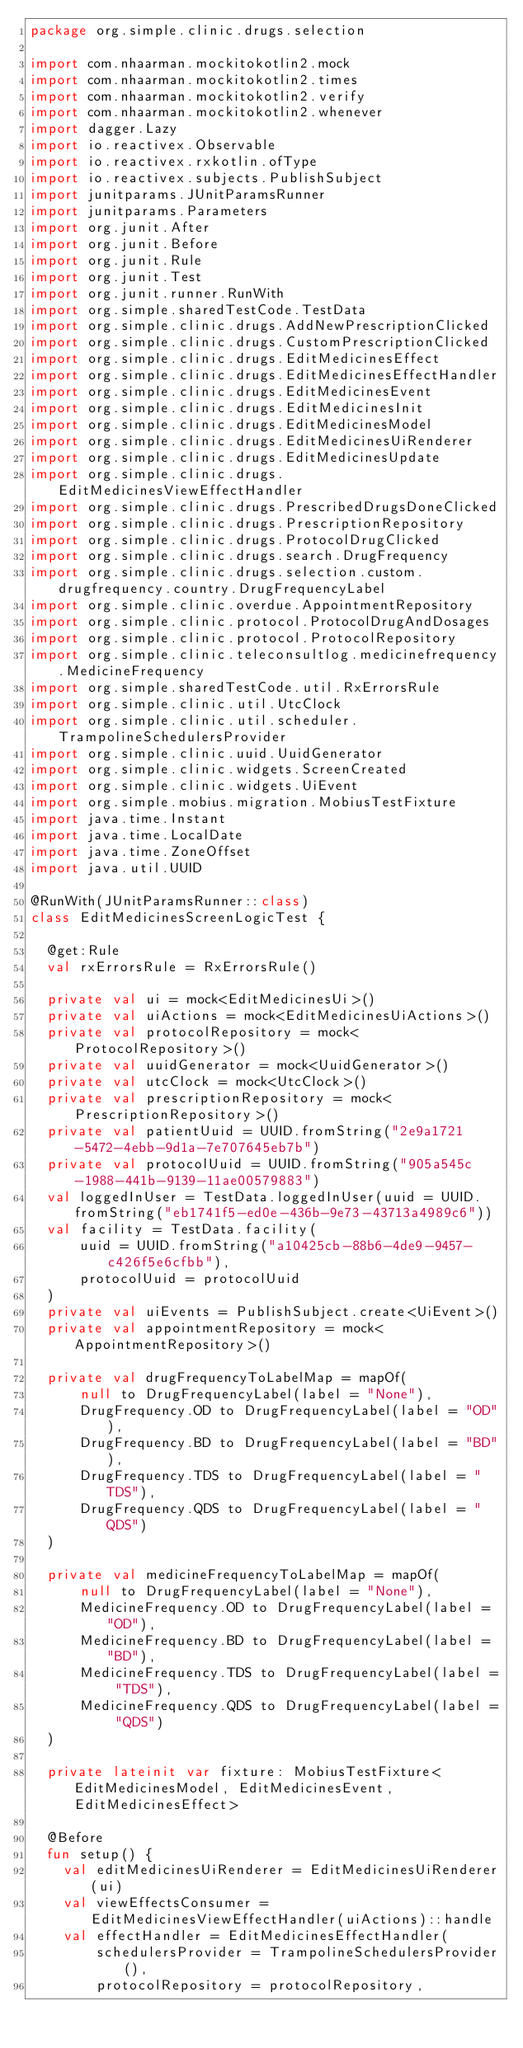Convert code to text. <code><loc_0><loc_0><loc_500><loc_500><_Kotlin_>package org.simple.clinic.drugs.selection

import com.nhaarman.mockitokotlin2.mock
import com.nhaarman.mockitokotlin2.times
import com.nhaarman.mockitokotlin2.verify
import com.nhaarman.mockitokotlin2.whenever
import dagger.Lazy
import io.reactivex.Observable
import io.reactivex.rxkotlin.ofType
import io.reactivex.subjects.PublishSubject
import junitparams.JUnitParamsRunner
import junitparams.Parameters
import org.junit.After
import org.junit.Before
import org.junit.Rule
import org.junit.Test
import org.junit.runner.RunWith
import org.simple.sharedTestCode.TestData
import org.simple.clinic.drugs.AddNewPrescriptionClicked
import org.simple.clinic.drugs.CustomPrescriptionClicked
import org.simple.clinic.drugs.EditMedicinesEffect
import org.simple.clinic.drugs.EditMedicinesEffectHandler
import org.simple.clinic.drugs.EditMedicinesEvent
import org.simple.clinic.drugs.EditMedicinesInit
import org.simple.clinic.drugs.EditMedicinesModel
import org.simple.clinic.drugs.EditMedicinesUiRenderer
import org.simple.clinic.drugs.EditMedicinesUpdate
import org.simple.clinic.drugs.EditMedicinesViewEffectHandler
import org.simple.clinic.drugs.PrescribedDrugsDoneClicked
import org.simple.clinic.drugs.PrescriptionRepository
import org.simple.clinic.drugs.ProtocolDrugClicked
import org.simple.clinic.drugs.search.DrugFrequency
import org.simple.clinic.drugs.selection.custom.drugfrequency.country.DrugFrequencyLabel
import org.simple.clinic.overdue.AppointmentRepository
import org.simple.clinic.protocol.ProtocolDrugAndDosages
import org.simple.clinic.protocol.ProtocolRepository
import org.simple.clinic.teleconsultlog.medicinefrequency.MedicineFrequency
import org.simple.sharedTestCode.util.RxErrorsRule
import org.simple.clinic.util.UtcClock
import org.simple.clinic.util.scheduler.TrampolineSchedulersProvider
import org.simple.clinic.uuid.UuidGenerator
import org.simple.clinic.widgets.ScreenCreated
import org.simple.clinic.widgets.UiEvent
import org.simple.mobius.migration.MobiusTestFixture
import java.time.Instant
import java.time.LocalDate
import java.time.ZoneOffset
import java.util.UUID

@RunWith(JUnitParamsRunner::class)
class EditMedicinesScreenLogicTest {

  @get:Rule
  val rxErrorsRule = RxErrorsRule()

  private val ui = mock<EditMedicinesUi>()
  private val uiActions = mock<EditMedicinesUiActions>()
  private val protocolRepository = mock<ProtocolRepository>()
  private val uuidGenerator = mock<UuidGenerator>()
  private val utcClock = mock<UtcClock>()
  private val prescriptionRepository = mock<PrescriptionRepository>()
  private val patientUuid = UUID.fromString("2e9a1721-5472-4ebb-9d1a-7e707645eb7b")
  private val protocolUuid = UUID.fromString("905a545c-1988-441b-9139-11ae00579883")
  val loggedInUser = TestData.loggedInUser(uuid = UUID.fromString("eb1741f5-ed0e-436b-9e73-43713a4989c6"))
  val facility = TestData.facility(
      uuid = UUID.fromString("a10425cb-88b6-4de9-9457-c426f5e6cfbb"),
      protocolUuid = protocolUuid
  )
  private val uiEvents = PublishSubject.create<UiEvent>()
  private val appointmentRepository = mock<AppointmentRepository>()

  private val drugFrequencyToLabelMap = mapOf(
      null to DrugFrequencyLabel(label = "None"),
      DrugFrequency.OD to DrugFrequencyLabel(label = "OD"),
      DrugFrequency.BD to DrugFrequencyLabel(label = "BD"),
      DrugFrequency.TDS to DrugFrequencyLabel(label = "TDS"),
      DrugFrequency.QDS to DrugFrequencyLabel(label = "QDS")
  )

  private val medicineFrequencyToLabelMap = mapOf(
      null to DrugFrequencyLabel(label = "None"),
      MedicineFrequency.OD to DrugFrequencyLabel(label = "OD"),
      MedicineFrequency.BD to DrugFrequencyLabel(label = "BD"),
      MedicineFrequency.TDS to DrugFrequencyLabel(label = "TDS"),
      MedicineFrequency.QDS to DrugFrequencyLabel(label = "QDS")
  )

  private lateinit var fixture: MobiusTestFixture<EditMedicinesModel, EditMedicinesEvent, EditMedicinesEffect>

  @Before
  fun setup() {
    val editMedicinesUiRenderer = EditMedicinesUiRenderer(ui)
    val viewEffectsConsumer = EditMedicinesViewEffectHandler(uiActions)::handle
    val effectHandler = EditMedicinesEffectHandler(
        schedulersProvider = TrampolineSchedulersProvider(),
        protocolRepository = protocolRepository,</code> 